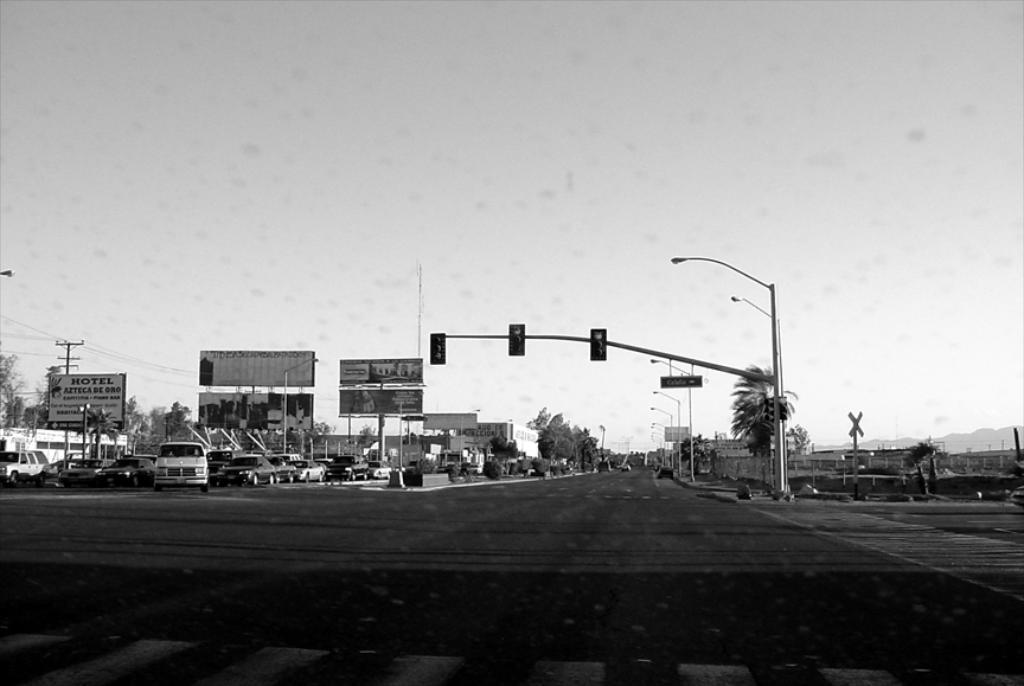Please provide a concise description of this image. It is a black and white image. In this image we can see many vehicles, hoardings, trees and also some buildings. We can also see the bushes, light poles, electrical pole with wires. At the top there is sky and at the bottom we can see the road. 